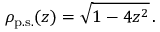<formula> <loc_0><loc_0><loc_500><loc_500>\rho _ { p . s . } ( z ) = \sqrt { 1 - 4 z ^ { 2 } } \, .</formula> 